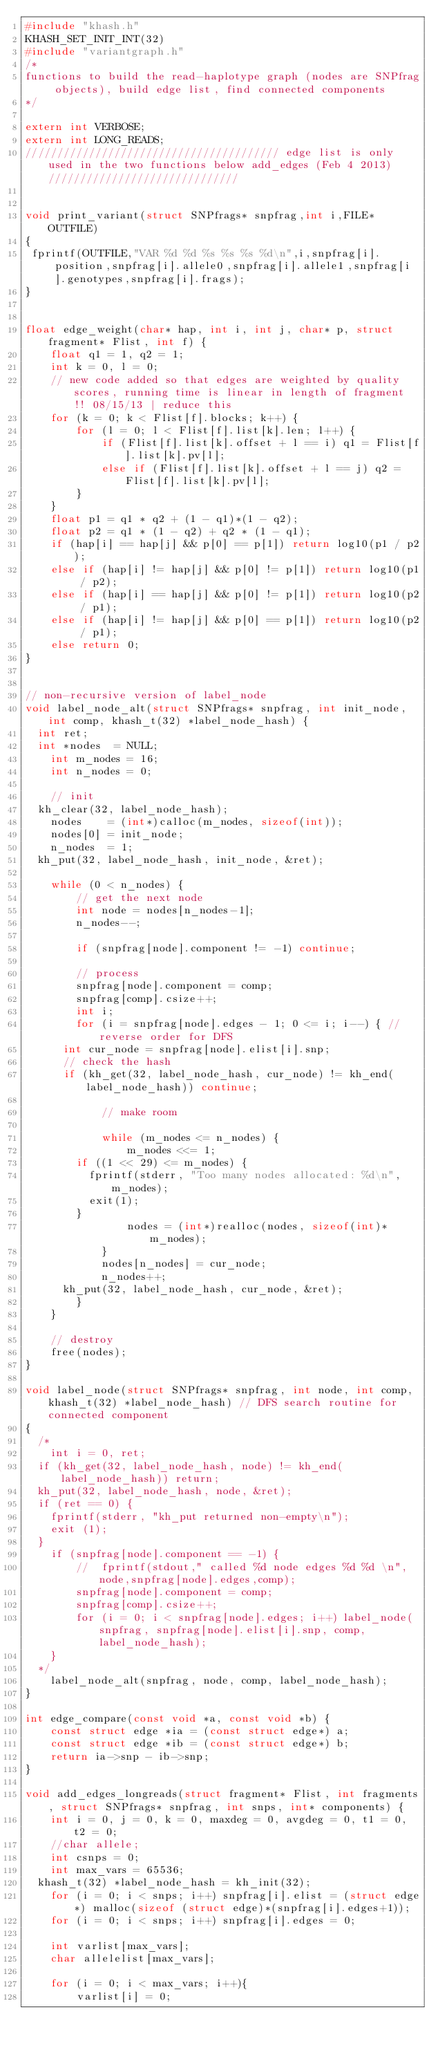<code> <loc_0><loc_0><loc_500><loc_500><_C_>#include "khash.h"
KHASH_SET_INIT_INT(32)
#include "variantgraph.h"
/*
functions to build the read-haplotype graph (nodes are SNPfrag objects), build edge list, find connected components
*/

extern int VERBOSE;
extern int LONG_READS;
//////////////////////////////////////// edge list is only used in the two functions below add_edges (Feb 4 2013) //////////////////////////////


void print_variant(struct SNPfrags* snpfrag,int i,FILE* OUTFILE)
{ 
 fprintf(OUTFILE,"VAR %d %d %s %s %s %d\n",i,snpfrag[i].position,snpfrag[i].allele0,snpfrag[i].allele1,snpfrag[i].genotypes,snpfrag[i].frags);
}


float edge_weight(char* hap, int i, int j, char* p, struct fragment* Flist, int f) {
    float q1 = 1, q2 = 1;
    int k = 0, l = 0;
    // new code added so that edges are weighted by quality scores, running time is linear in length of fragment !! 08/15/13 | reduce this
    for (k = 0; k < Flist[f].blocks; k++) {
        for (l = 0; l < Flist[f].list[k].len; l++) {
            if (Flist[f].list[k].offset + l == i) q1 = Flist[f].list[k].pv[l];
            else if (Flist[f].list[k].offset + l == j) q2 = Flist[f].list[k].pv[l];
        }
    }
    float p1 = q1 * q2 + (1 - q1)*(1 - q2);
    float p2 = q1 * (1 - q2) + q2 * (1 - q1);
    if (hap[i] == hap[j] && p[0] == p[1]) return log10(p1 / p2);
    else if (hap[i] != hap[j] && p[0] != p[1]) return log10(p1 / p2);
    else if (hap[i] == hap[j] && p[0] != p[1]) return log10(p2 / p1);
    else if (hap[i] != hap[j] && p[0] == p[1]) return log10(p2 / p1);
    else return 0;
}


// non-recursive version of label_node
void label_node_alt(struct SNPfrags* snpfrag, int init_node, int comp, khash_t(32) *label_node_hash) {
	int ret;
	int *nodes  = NULL;
    int m_nodes = 16;
    int n_nodes = 0;

    // init
	kh_clear(32, label_node_hash);
    nodes    = (int*)calloc(m_nodes, sizeof(int));
    nodes[0] = init_node;
    n_nodes  = 1;
	kh_put(32, label_node_hash, init_node, &ret);

    while (0 < n_nodes) {
        // get the next node
        int node = nodes[n_nodes-1];
        n_nodes--;

        if (snpfrag[node].component != -1) continue;

        // process
        snpfrag[node].component = comp;
        snpfrag[comp].csize++;
        int i;
        for (i = snpfrag[node].edges - 1; 0 <= i; i--) { // reverse order for DFS
			int cur_node = snpfrag[node].elist[i].snp;
			// check the hash
			if (kh_get(32, label_node_hash, cur_node) != kh_end(label_node_hash)) continue;

            // make room

            while (m_nodes <= n_nodes) {
                m_nodes <<= 1;
				if ((1 << 29) <= m_nodes) {
					fprintf(stderr, "Too many nodes allocated: %d\n", m_nodes);
					exit(1);
				}
                nodes = (int*)realloc(nodes, sizeof(int)*m_nodes);
            }
            nodes[n_nodes] = cur_node;
            n_nodes++;
			kh_put(32, label_node_hash, cur_node, &ret);
        }
    }

    // destroy
    free(nodes);
}

void label_node(struct SNPfrags* snpfrag, int node, int comp, khash_t(32) *label_node_hash) // DFS search routine for connected component
{
	/*
    int i = 0, ret;
	if (kh_get(32, label_node_hash, node) != kh_end(label_node_hash)) return;
	kh_put(32, label_node_hash, node, &ret);
	if (ret == 0) {
		fprintf(stderr, "kh_put returned non-empty\n");
		exit (1);
	}
    if (snpfrag[node].component == -1) {
        //  fprintf(stdout," called %d node edges %d %d \n",node,snpfrag[node].edges,comp);
        snpfrag[node].component = comp;
        snpfrag[comp].csize++;
        for (i = 0; i < snpfrag[node].edges; i++) label_node(snpfrag, snpfrag[node].elist[i].snp, comp, label_node_hash);
    }
	*/
    label_node_alt(snpfrag, node, comp, label_node_hash);
}

int edge_compare(const void *a, const void *b) {
    const struct edge *ia = (const struct edge*) a;
    const struct edge *ib = (const struct edge*) b;
    return ia->snp - ib->snp;
}

void add_edges_longreads(struct fragment* Flist, int fragments, struct SNPfrags* snpfrag, int snps, int* components) {
    int i = 0, j = 0, k = 0, maxdeg = 0, avgdeg = 0, t1 = 0, t2 = 0;
    //char allele;
    int csnps = 0;
    int max_vars = 65536;
	khash_t(32) *label_node_hash = kh_init(32);
    for (i = 0; i < snps; i++) snpfrag[i].elist = (struct edge*) malloc(sizeof (struct edge)*(snpfrag[i].edges+1));
    for (i = 0; i < snps; i++) snpfrag[i].edges = 0;

    int varlist[max_vars];
    char allelelist[max_vars];

    for (i = 0; i < max_vars; i++){
        varlist[i] = 0;</code> 